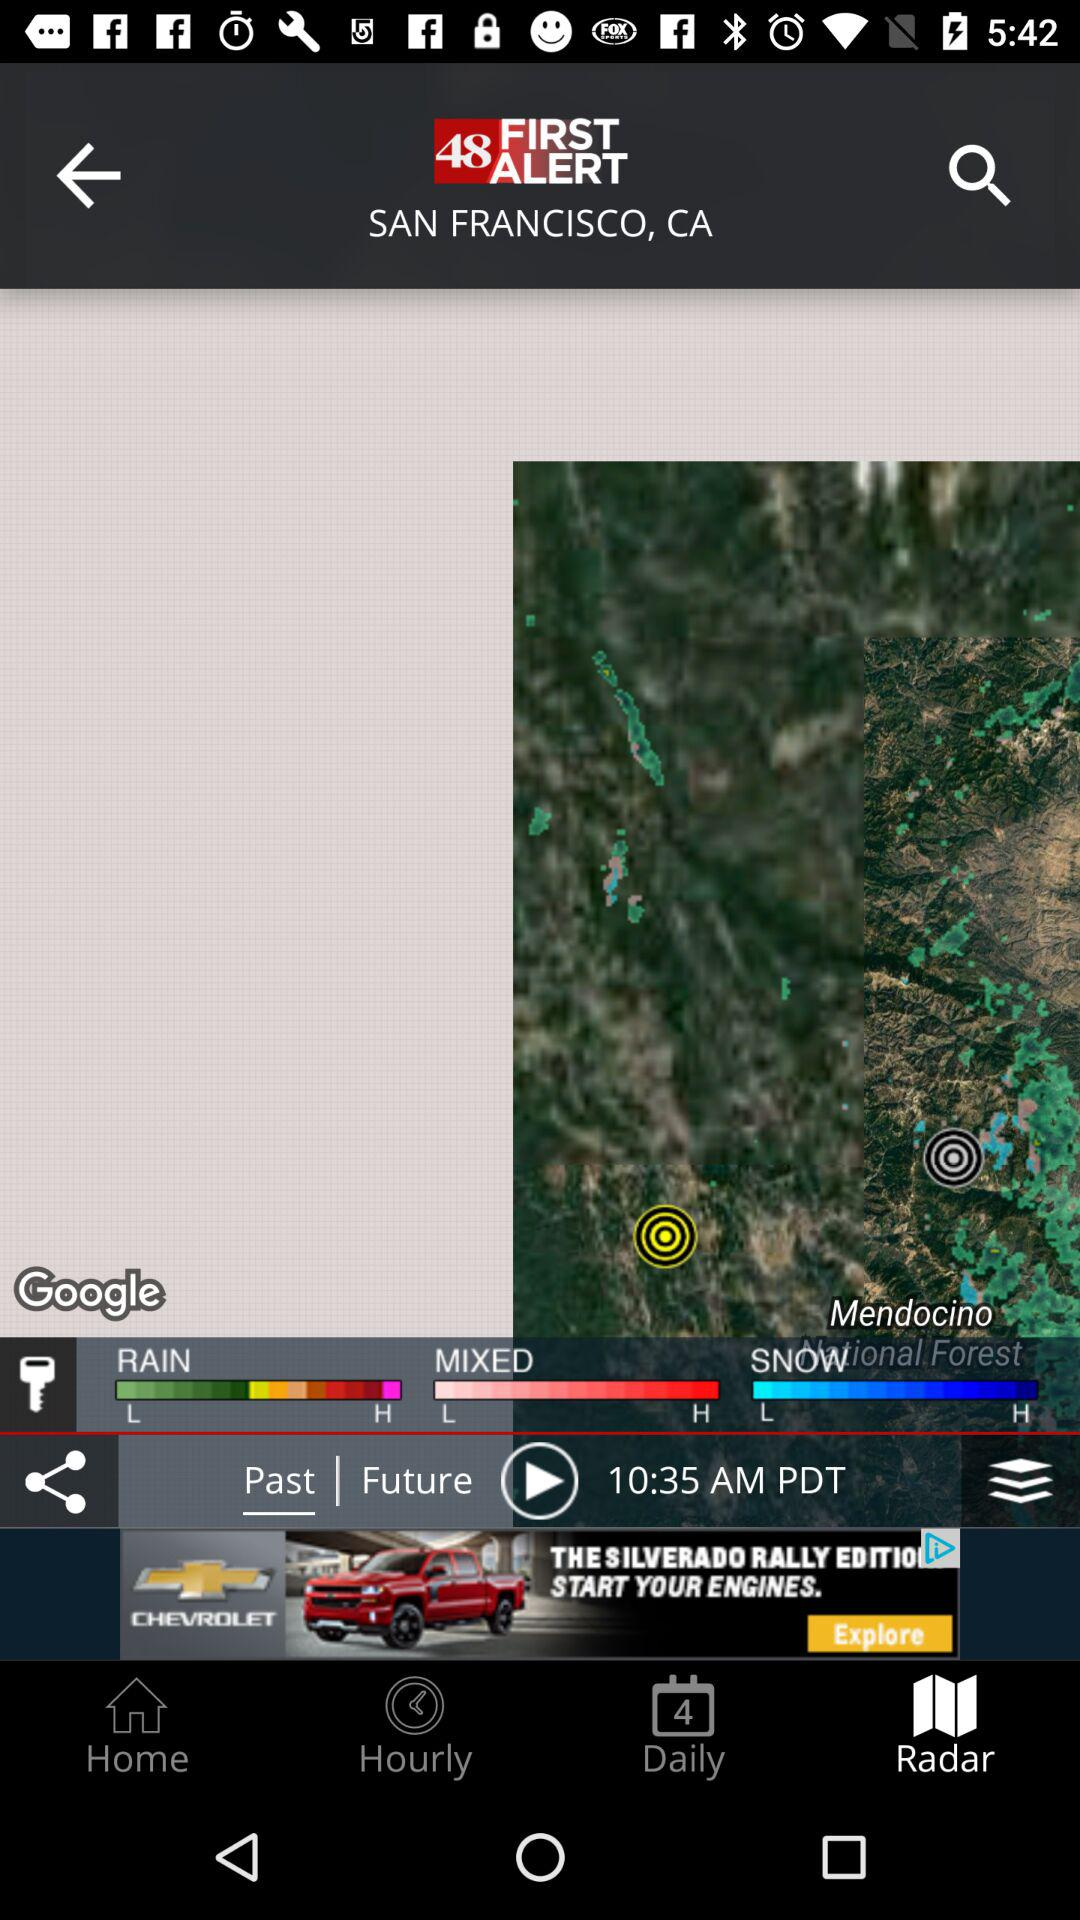How many time periods are available?
Answer the question using a single word or phrase. 3 